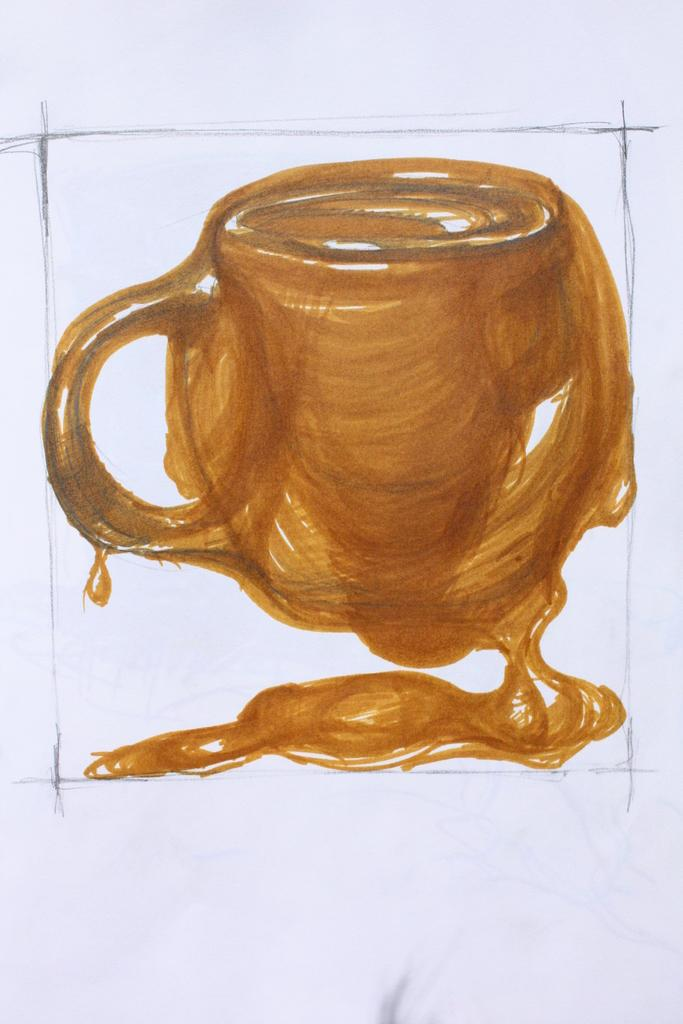What is the main subject of the image? The main subject of the image is a cup. What can be said about the color of the cup? The cup is white in color. What type of linen is used to cover the cup in the image? There is no linen present in the image, as it is a drawing of a cup. What game is being played with the cup in the image? There is no game being played with the cup in the image; it is simply a drawing of a cup. 